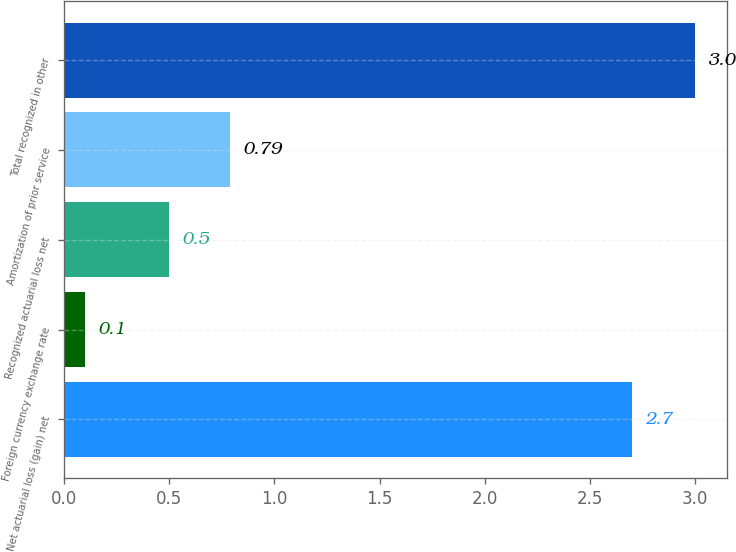Convert chart. <chart><loc_0><loc_0><loc_500><loc_500><bar_chart><fcel>Net actuarial loss (gain) net<fcel>Foreign currency exchange rate<fcel>Recognized actuarial loss net<fcel>Amortization of prior service<fcel>Total recognized in other<nl><fcel>2.7<fcel>0.1<fcel>0.5<fcel>0.79<fcel>3<nl></chart> 